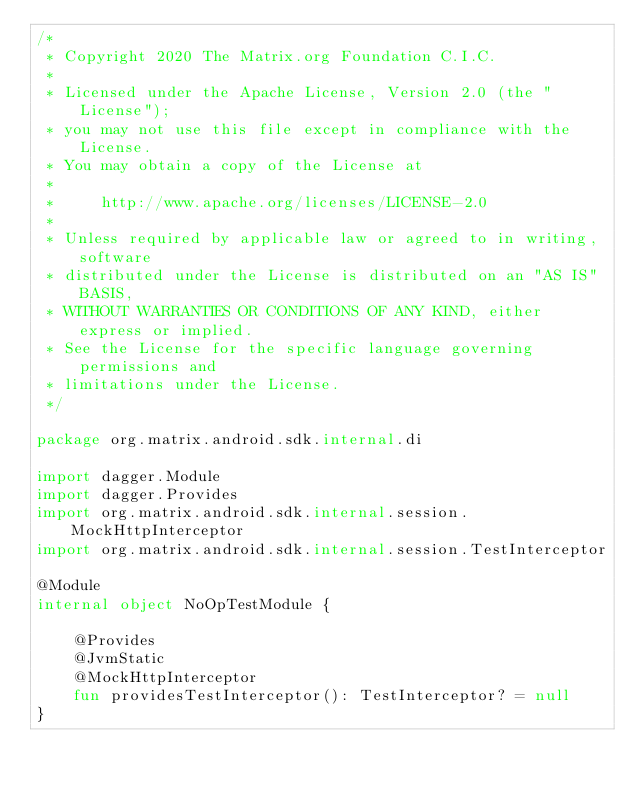<code> <loc_0><loc_0><loc_500><loc_500><_Kotlin_>/*
 * Copyright 2020 The Matrix.org Foundation C.I.C.
 *
 * Licensed under the Apache License, Version 2.0 (the "License");
 * you may not use this file except in compliance with the License.
 * You may obtain a copy of the License at
 *
 *     http://www.apache.org/licenses/LICENSE-2.0
 *
 * Unless required by applicable law or agreed to in writing, software
 * distributed under the License is distributed on an "AS IS" BASIS,
 * WITHOUT WARRANTIES OR CONDITIONS OF ANY KIND, either express or implied.
 * See the License for the specific language governing permissions and
 * limitations under the License.
 */

package org.matrix.android.sdk.internal.di

import dagger.Module
import dagger.Provides
import org.matrix.android.sdk.internal.session.MockHttpInterceptor
import org.matrix.android.sdk.internal.session.TestInterceptor

@Module
internal object NoOpTestModule {

    @Provides
    @JvmStatic
    @MockHttpInterceptor
    fun providesTestInterceptor(): TestInterceptor? = null
}
</code> 